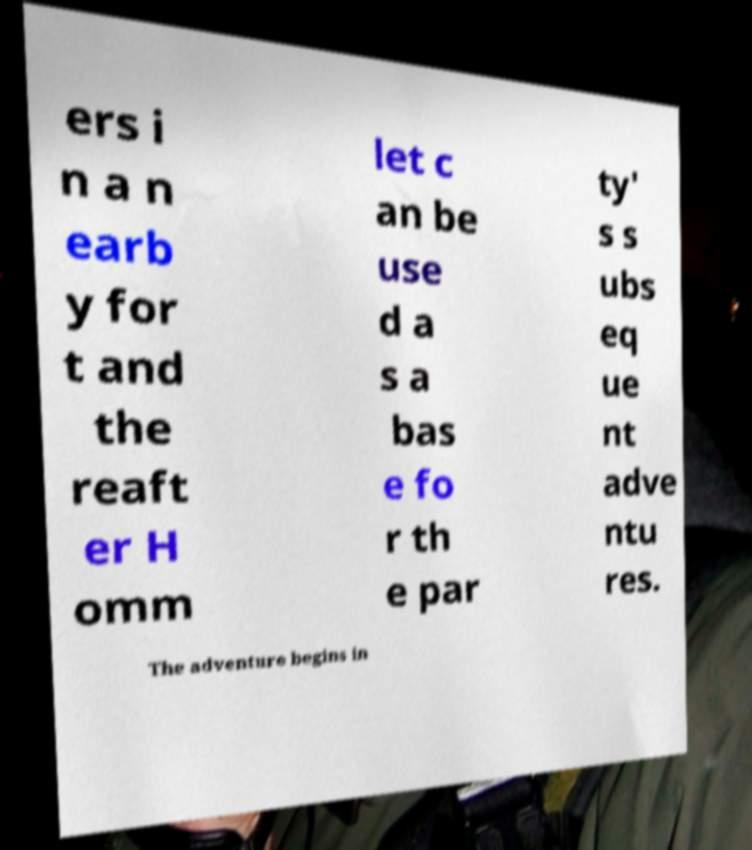Could you extract and type out the text from this image? ers i n a n earb y for t and the reaft er H omm let c an be use d a s a bas e fo r th e par ty' s s ubs eq ue nt adve ntu res. The adventure begins in 